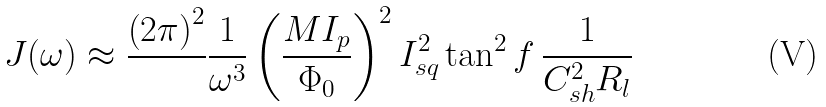<formula> <loc_0><loc_0><loc_500><loc_500>J ( \omega ) \approx \frac { \left ( 2 \pi \right ) ^ { 2 } } { } \frac { 1 } { \omega ^ { 3 } } \left ( \frac { M I _ { p } } { \Phi _ { 0 } } \right ) ^ { 2 } I _ { s q } ^ { 2 } \tan ^ { 2 } f \, \frac { 1 } { C _ { s h } ^ { 2 } R _ { l } }</formula> 